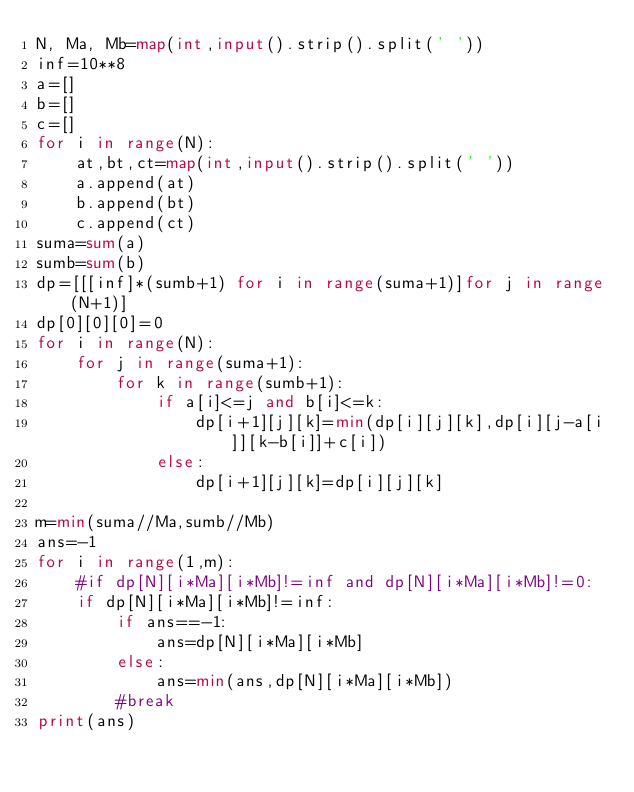<code> <loc_0><loc_0><loc_500><loc_500><_Python_>N, Ma, Mb=map(int,input().strip().split(' '))
inf=10**8
a=[]
b=[]
c=[]
for i in range(N):
    at,bt,ct=map(int,input().strip().split(' '))
    a.append(at)
    b.append(bt)
    c.append(ct)
suma=sum(a)
sumb=sum(b)
dp=[[[inf]*(sumb+1) for i in range(suma+1)]for j in range(N+1)]
dp[0][0][0]=0
for i in range(N):
    for j in range(suma+1):
        for k in range(sumb+1):
            if a[i]<=j and b[i]<=k:
                dp[i+1][j][k]=min(dp[i][j][k],dp[i][j-a[i]][k-b[i]]+c[i])
            else:
                dp[i+1][j][k]=dp[i][j][k]
            
m=min(suma//Ma,sumb//Mb)
ans=-1
for i in range(1,m):
    #if dp[N][i*Ma][i*Mb]!=inf and dp[N][i*Ma][i*Mb]!=0:
    if dp[N][i*Ma][i*Mb]!=inf:
        if ans==-1:
            ans=dp[N][i*Ma][i*Mb]
        else:
            ans=min(ans,dp[N][i*Ma][i*Mb])
        #break
print(ans)</code> 